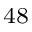Convert formula to latex. <formula><loc_0><loc_0><loc_500><loc_500>^ { 4 8 }</formula> 